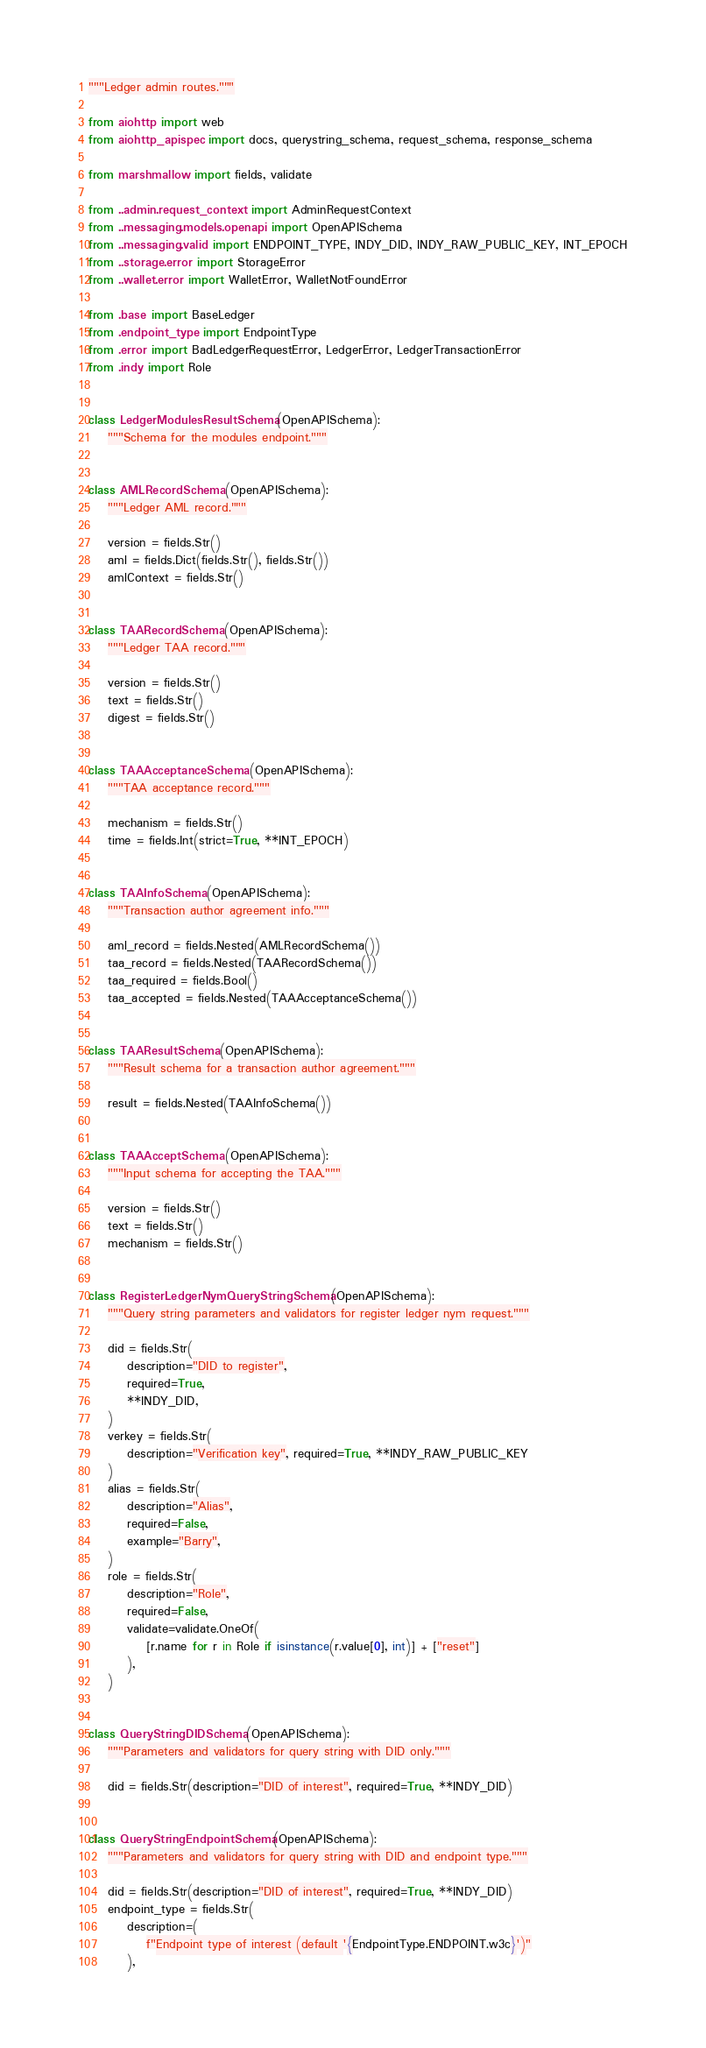<code> <loc_0><loc_0><loc_500><loc_500><_Python_>"""Ledger admin routes."""

from aiohttp import web
from aiohttp_apispec import docs, querystring_schema, request_schema, response_schema

from marshmallow import fields, validate

from ..admin.request_context import AdminRequestContext
from ..messaging.models.openapi import OpenAPISchema
from ..messaging.valid import ENDPOINT_TYPE, INDY_DID, INDY_RAW_PUBLIC_KEY, INT_EPOCH
from ..storage.error import StorageError
from ..wallet.error import WalletError, WalletNotFoundError

from .base import BaseLedger
from .endpoint_type import EndpointType
from .error import BadLedgerRequestError, LedgerError, LedgerTransactionError
from .indy import Role


class LedgerModulesResultSchema(OpenAPISchema):
    """Schema for the modules endpoint."""


class AMLRecordSchema(OpenAPISchema):
    """Ledger AML record."""

    version = fields.Str()
    aml = fields.Dict(fields.Str(), fields.Str())
    amlContext = fields.Str()


class TAARecordSchema(OpenAPISchema):
    """Ledger TAA record."""

    version = fields.Str()
    text = fields.Str()
    digest = fields.Str()


class TAAAcceptanceSchema(OpenAPISchema):
    """TAA acceptance record."""

    mechanism = fields.Str()
    time = fields.Int(strict=True, **INT_EPOCH)


class TAAInfoSchema(OpenAPISchema):
    """Transaction author agreement info."""

    aml_record = fields.Nested(AMLRecordSchema())
    taa_record = fields.Nested(TAARecordSchema())
    taa_required = fields.Bool()
    taa_accepted = fields.Nested(TAAAcceptanceSchema())


class TAAResultSchema(OpenAPISchema):
    """Result schema for a transaction author agreement."""

    result = fields.Nested(TAAInfoSchema())


class TAAAcceptSchema(OpenAPISchema):
    """Input schema for accepting the TAA."""

    version = fields.Str()
    text = fields.Str()
    mechanism = fields.Str()


class RegisterLedgerNymQueryStringSchema(OpenAPISchema):
    """Query string parameters and validators for register ledger nym request."""

    did = fields.Str(
        description="DID to register",
        required=True,
        **INDY_DID,
    )
    verkey = fields.Str(
        description="Verification key", required=True, **INDY_RAW_PUBLIC_KEY
    )
    alias = fields.Str(
        description="Alias",
        required=False,
        example="Barry",
    )
    role = fields.Str(
        description="Role",
        required=False,
        validate=validate.OneOf(
            [r.name for r in Role if isinstance(r.value[0], int)] + ["reset"]
        ),
    )


class QueryStringDIDSchema(OpenAPISchema):
    """Parameters and validators for query string with DID only."""

    did = fields.Str(description="DID of interest", required=True, **INDY_DID)


class QueryStringEndpointSchema(OpenAPISchema):
    """Parameters and validators for query string with DID and endpoint type."""

    did = fields.Str(description="DID of interest", required=True, **INDY_DID)
    endpoint_type = fields.Str(
        description=(
            f"Endpoint type of interest (default '{EndpointType.ENDPOINT.w3c}')"
        ),</code> 